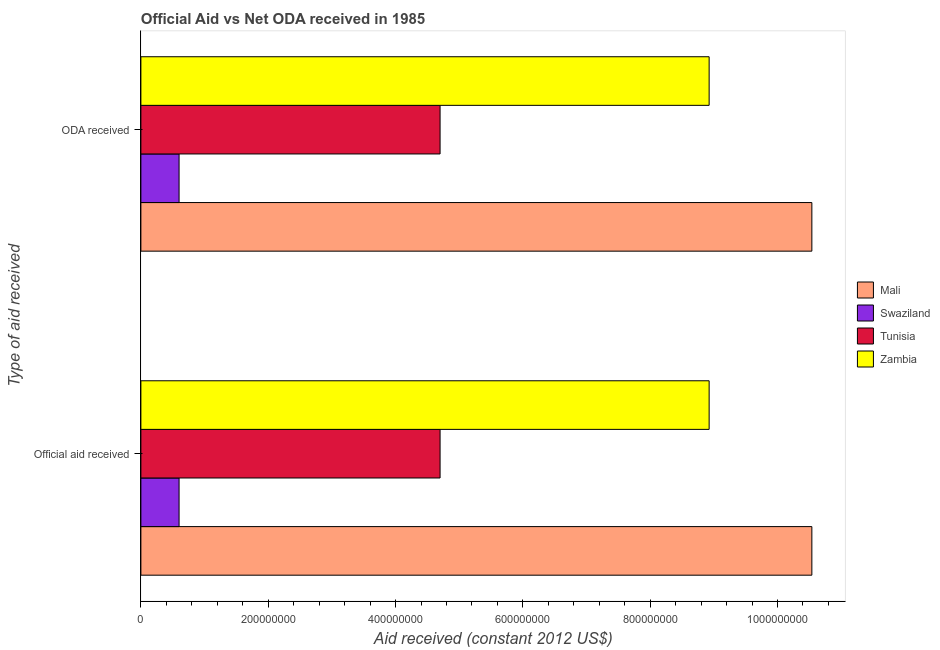How many different coloured bars are there?
Your answer should be very brief. 4. How many bars are there on the 2nd tick from the bottom?
Make the answer very short. 4. What is the label of the 2nd group of bars from the top?
Keep it short and to the point. Official aid received. What is the official aid received in Mali?
Provide a short and direct response. 1.05e+09. Across all countries, what is the maximum oda received?
Your response must be concise. 1.05e+09. Across all countries, what is the minimum oda received?
Your response must be concise. 6.00e+07. In which country was the oda received maximum?
Your answer should be compact. Mali. In which country was the oda received minimum?
Provide a succinct answer. Swaziland. What is the total official aid received in the graph?
Your response must be concise. 2.48e+09. What is the difference between the official aid received in Zambia and that in Mali?
Provide a succinct answer. -1.61e+08. What is the difference between the official aid received in Zambia and the oda received in Mali?
Provide a short and direct response. -1.61e+08. What is the average oda received per country?
Offer a very short reply. 6.19e+08. What is the ratio of the official aid received in Swaziland to that in Tunisia?
Make the answer very short. 0.13. What does the 2nd bar from the top in ODA received represents?
Ensure brevity in your answer.  Tunisia. What does the 2nd bar from the bottom in ODA received represents?
Make the answer very short. Swaziland. Are the values on the major ticks of X-axis written in scientific E-notation?
Make the answer very short. No. Does the graph contain any zero values?
Offer a very short reply. No. How many legend labels are there?
Provide a short and direct response. 4. What is the title of the graph?
Your answer should be very brief. Official Aid vs Net ODA received in 1985 . What is the label or title of the X-axis?
Your answer should be very brief. Aid received (constant 2012 US$). What is the label or title of the Y-axis?
Your response must be concise. Type of aid received. What is the Aid received (constant 2012 US$) of Mali in Official aid received?
Ensure brevity in your answer.  1.05e+09. What is the Aid received (constant 2012 US$) of Swaziland in Official aid received?
Provide a succinct answer. 6.00e+07. What is the Aid received (constant 2012 US$) in Tunisia in Official aid received?
Ensure brevity in your answer.  4.70e+08. What is the Aid received (constant 2012 US$) in Zambia in Official aid received?
Your response must be concise. 8.93e+08. What is the Aid received (constant 2012 US$) of Mali in ODA received?
Provide a succinct answer. 1.05e+09. What is the Aid received (constant 2012 US$) of Swaziland in ODA received?
Ensure brevity in your answer.  6.00e+07. What is the Aid received (constant 2012 US$) of Tunisia in ODA received?
Make the answer very short. 4.70e+08. What is the Aid received (constant 2012 US$) in Zambia in ODA received?
Offer a terse response. 8.93e+08. Across all Type of aid received, what is the maximum Aid received (constant 2012 US$) in Mali?
Your response must be concise. 1.05e+09. Across all Type of aid received, what is the maximum Aid received (constant 2012 US$) of Swaziland?
Offer a terse response. 6.00e+07. Across all Type of aid received, what is the maximum Aid received (constant 2012 US$) of Tunisia?
Your answer should be very brief. 4.70e+08. Across all Type of aid received, what is the maximum Aid received (constant 2012 US$) in Zambia?
Provide a short and direct response. 8.93e+08. Across all Type of aid received, what is the minimum Aid received (constant 2012 US$) in Mali?
Provide a succinct answer. 1.05e+09. Across all Type of aid received, what is the minimum Aid received (constant 2012 US$) in Swaziland?
Provide a succinct answer. 6.00e+07. Across all Type of aid received, what is the minimum Aid received (constant 2012 US$) of Tunisia?
Offer a very short reply. 4.70e+08. Across all Type of aid received, what is the minimum Aid received (constant 2012 US$) of Zambia?
Provide a short and direct response. 8.93e+08. What is the total Aid received (constant 2012 US$) of Mali in the graph?
Ensure brevity in your answer.  2.11e+09. What is the total Aid received (constant 2012 US$) in Swaziland in the graph?
Your response must be concise. 1.20e+08. What is the total Aid received (constant 2012 US$) of Tunisia in the graph?
Provide a succinct answer. 9.40e+08. What is the total Aid received (constant 2012 US$) of Zambia in the graph?
Offer a terse response. 1.79e+09. What is the difference between the Aid received (constant 2012 US$) in Swaziland in Official aid received and that in ODA received?
Keep it short and to the point. 0. What is the difference between the Aid received (constant 2012 US$) in Zambia in Official aid received and that in ODA received?
Your answer should be very brief. 0. What is the difference between the Aid received (constant 2012 US$) in Mali in Official aid received and the Aid received (constant 2012 US$) in Swaziland in ODA received?
Offer a very short reply. 9.94e+08. What is the difference between the Aid received (constant 2012 US$) of Mali in Official aid received and the Aid received (constant 2012 US$) of Tunisia in ODA received?
Keep it short and to the point. 5.84e+08. What is the difference between the Aid received (constant 2012 US$) of Mali in Official aid received and the Aid received (constant 2012 US$) of Zambia in ODA received?
Your answer should be very brief. 1.61e+08. What is the difference between the Aid received (constant 2012 US$) in Swaziland in Official aid received and the Aid received (constant 2012 US$) in Tunisia in ODA received?
Your answer should be very brief. -4.10e+08. What is the difference between the Aid received (constant 2012 US$) of Swaziland in Official aid received and the Aid received (constant 2012 US$) of Zambia in ODA received?
Keep it short and to the point. -8.33e+08. What is the difference between the Aid received (constant 2012 US$) of Tunisia in Official aid received and the Aid received (constant 2012 US$) of Zambia in ODA received?
Provide a short and direct response. -4.23e+08. What is the average Aid received (constant 2012 US$) in Mali per Type of aid received?
Your answer should be compact. 1.05e+09. What is the average Aid received (constant 2012 US$) in Swaziland per Type of aid received?
Your answer should be very brief. 6.00e+07. What is the average Aid received (constant 2012 US$) in Tunisia per Type of aid received?
Make the answer very short. 4.70e+08. What is the average Aid received (constant 2012 US$) of Zambia per Type of aid received?
Offer a very short reply. 8.93e+08. What is the difference between the Aid received (constant 2012 US$) in Mali and Aid received (constant 2012 US$) in Swaziland in Official aid received?
Ensure brevity in your answer.  9.94e+08. What is the difference between the Aid received (constant 2012 US$) in Mali and Aid received (constant 2012 US$) in Tunisia in Official aid received?
Give a very brief answer. 5.84e+08. What is the difference between the Aid received (constant 2012 US$) in Mali and Aid received (constant 2012 US$) in Zambia in Official aid received?
Offer a terse response. 1.61e+08. What is the difference between the Aid received (constant 2012 US$) in Swaziland and Aid received (constant 2012 US$) in Tunisia in Official aid received?
Give a very brief answer. -4.10e+08. What is the difference between the Aid received (constant 2012 US$) of Swaziland and Aid received (constant 2012 US$) of Zambia in Official aid received?
Provide a short and direct response. -8.33e+08. What is the difference between the Aid received (constant 2012 US$) in Tunisia and Aid received (constant 2012 US$) in Zambia in Official aid received?
Your answer should be very brief. -4.23e+08. What is the difference between the Aid received (constant 2012 US$) of Mali and Aid received (constant 2012 US$) of Swaziland in ODA received?
Your answer should be compact. 9.94e+08. What is the difference between the Aid received (constant 2012 US$) of Mali and Aid received (constant 2012 US$) of Tunisia in ODA received?
Offer a very short reply. 5.84e+08. What is the difference between the Aid received (constant 2012 US$) in Mali and Aid received (constant 2012 US$) in Zambia in ODA received?
Keep it short and to the point. 1.61e+08. What is the difference between the Aid received (constant 2012 US$) in Swaziland and Aid received (constant 2012 US$) in Tunisia in ODA received?
Offer a very short reply. -4.10e+08. What is the difference between the Aid received (constant 2012 US$) of Swaziland and Aid received (constant 2012 US$) of Zambia in ODA received?
Make the answer very short. -8.33e+08. What is the difference between the Aid received (constant 2012 US$) in Tunisia and Aid received (constant 2012 US$) in Zambia in ODA received?
Offer a terse response. -4.23e+08. What is the ratio of the Aid received (constant 2012 US$) in Mali in Official aid received to that in ODA received?
Offer a terse response. 1. What is the difference between the highest and the second highest Aid received (constant 2012 US$) in Zambia?
Give a very brief answer. 0. What is the difference between the highest and the lowest Aid received (constant 2012 US$) of Mali?
Provide a short and direct response. 0. What is the difference between the highest and the lowest Aid received (constant 2012 US$) of Tunisia?
Offer a very short reply. 0. 